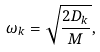Convert formula to latex. <formula><loc_0><loc_0><loc_500><loc_500>\omega _ { k } = \sqrt { \frac { 2 D _ { k } } { M } } ,</formula> 